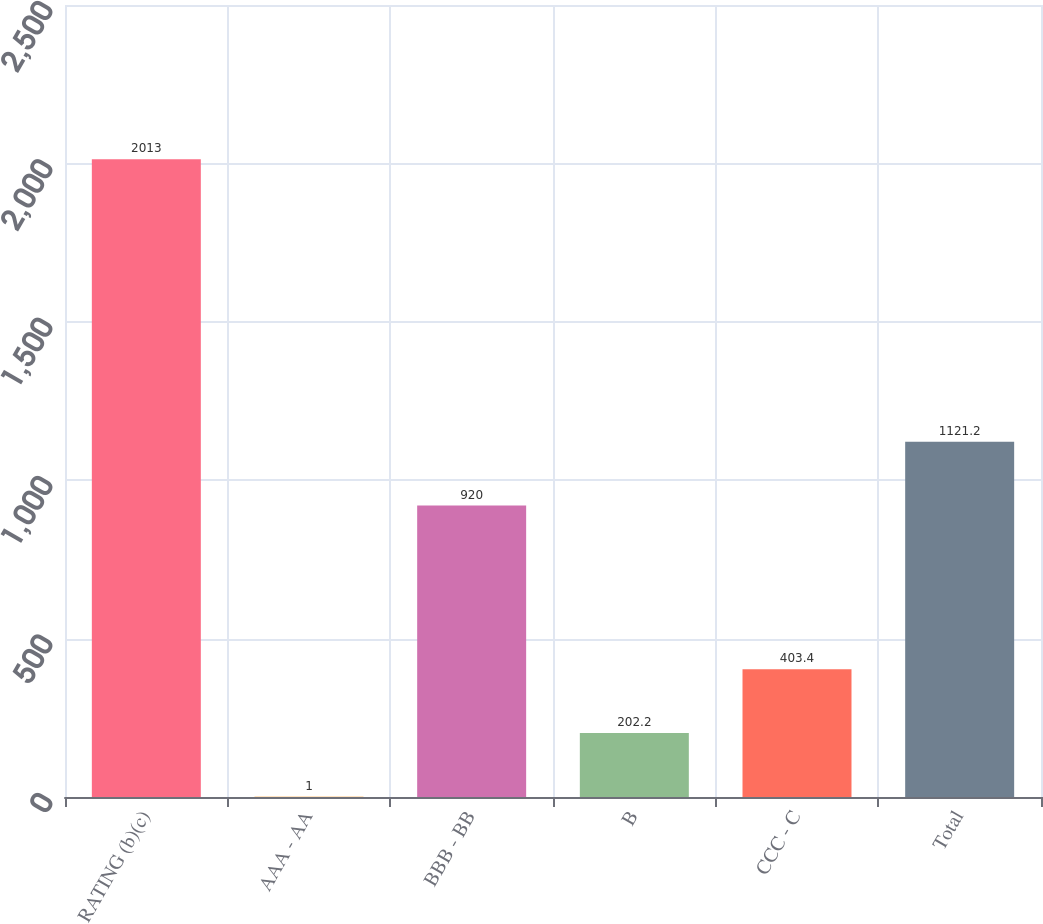Convert chart. <chart><loc_0><loc_0><loc_500><loc_500><bar_chart><fcel>RATING (b)(c)<fcel>AAA - AA<fcel>BBB - BB<fcel>B<fcel>CCC - C<fcel>Total<nl><fcel>2013<fcel>1<fcel>920<fcel>202.2<fcel>403.4<fcel>1121.2<nl></chart> 